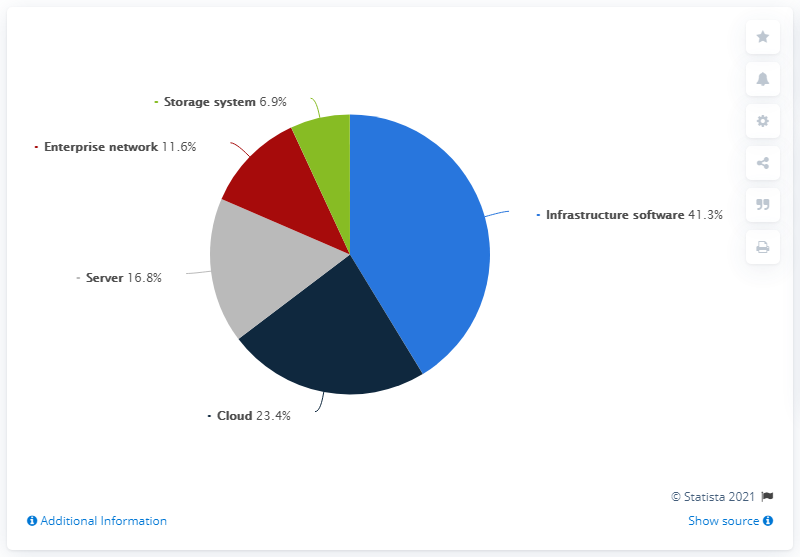Highlight a few significant elements in this photo. In June 2019, the infrastructure software segment of the enterprise IT market accounted for 41.3% of the total market share. The addition of Server and Cloud is greater than the Infrastructure software itself. There are three colored segments that are less than 20%. 